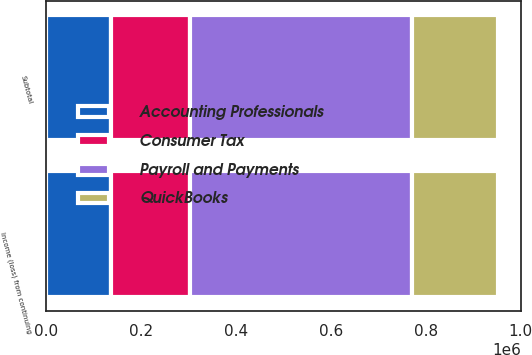<chart> <loc_0><loc_0><loc_500><loc_500><stacked_bar_chart><ecel><fcel>Subtotal<fcel>Income (loss) from continuing<nl><fcel>Consumer Tax<fcel>167397<fcel>167397<nl><fcel>QuickBooks<fcel>181927<fcel>181927<nl><fcel>Payroll and Payments<fcel>467118<fcel>467118<nl><fcel>Accounting Professionals<fcel>136663<fcel>136663<nl></chart> 